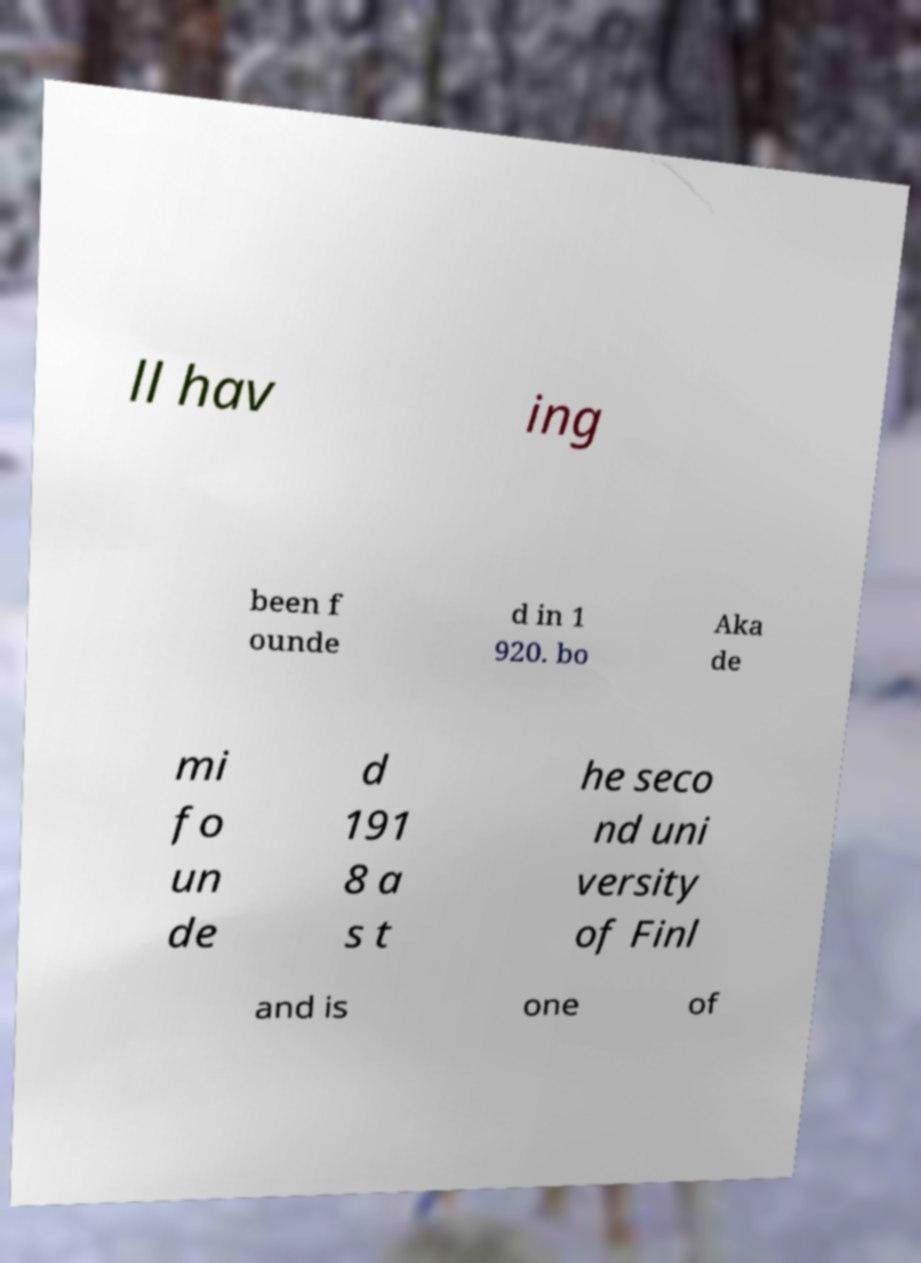For documentation purposes, I need the text within this image transcribed. Could you provide that? ll hav ing been f ounde d in 1 920. bo Aka de mi fo un de d 191 8 a s t he seco nd uni versity of Finl and is one of 